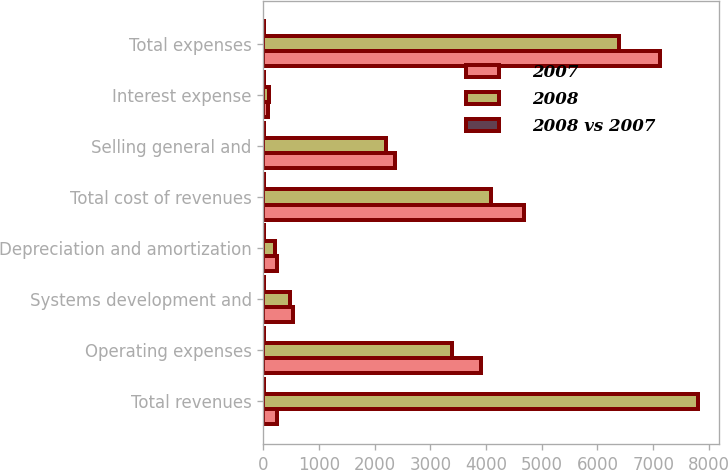Convert chart to OTSL. <chart><loc_0><loc_0><loc_500><loc_500><stacked_bar_chart><ecel><fcel>Total revenues<fcel>Operating expenses<fcel>Systems development and<fcel>Depreciation and amortization<fcel>Total cost of revenues<fcel>Selling general and<fcel>Interest expense<fcel>Total expenses<nl><fcel>2007<fcel>238.5<fcel>3915.7<fcel>525.9<fcel>238.5<fcel>4680.1<fcel>2370.4<fcel>80.5<fcel>7131<nl><fcel>2008<fcel>7800<fcel>3392.3<fcel>486.1<fcel>208.9<fcel>4087.3<fcel>2206.2<fcel>94.9<fcel>6388.4<nl><fcel>2008 vs 2007<fcel>13<fcel>15<fcel>8<fcel>14<fcel>15<fcel>7<fcel>15<fcel>12<nl></chart> 